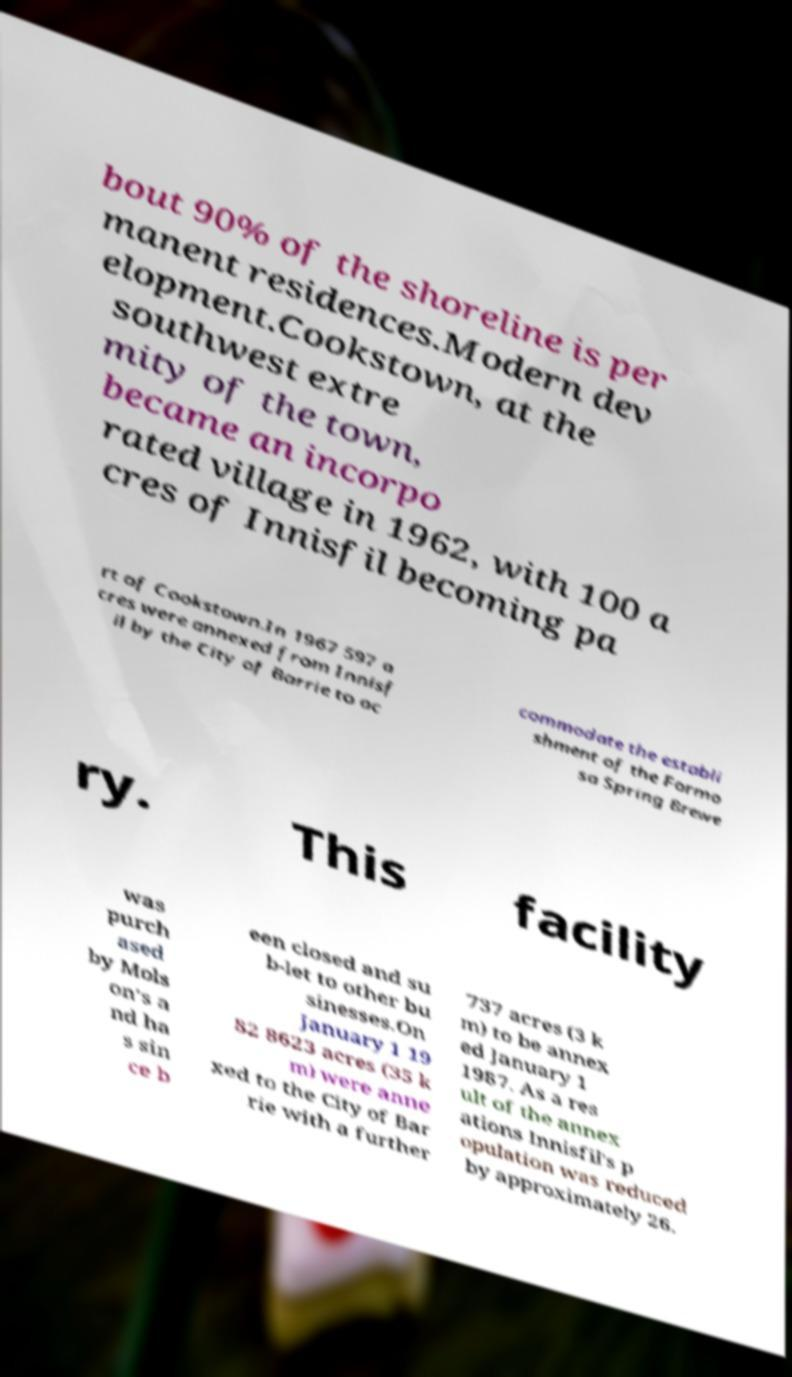I need the written content from this picture converted into text. Can you do that? bout 90% of the shoreline is per manent residences.Modern dev elopment.Cookstown, at the southwest extre mity of the town, became an incorpo rated village in 1962, with 100 a cres of Innisfil becoming pa rt of Cookstown.In 1967 597 a cres were annexed from Innisf il by the City of Barrie to ac commodate the establi shment of the Formo sa Spring Brewe ry. This facility was purch ased by Mols on's a nd ha s sin ce b een closed and su b-let to other bu sinesses.On January 1 19 82 8623 acres (35 k m) were anne xed to the City of Bar rie with a further 737 acres (3 k m) to be annex ed January 1 1987. As a res ult of the annex ations Innisfil's p opulation was reduced by approximately 26. 